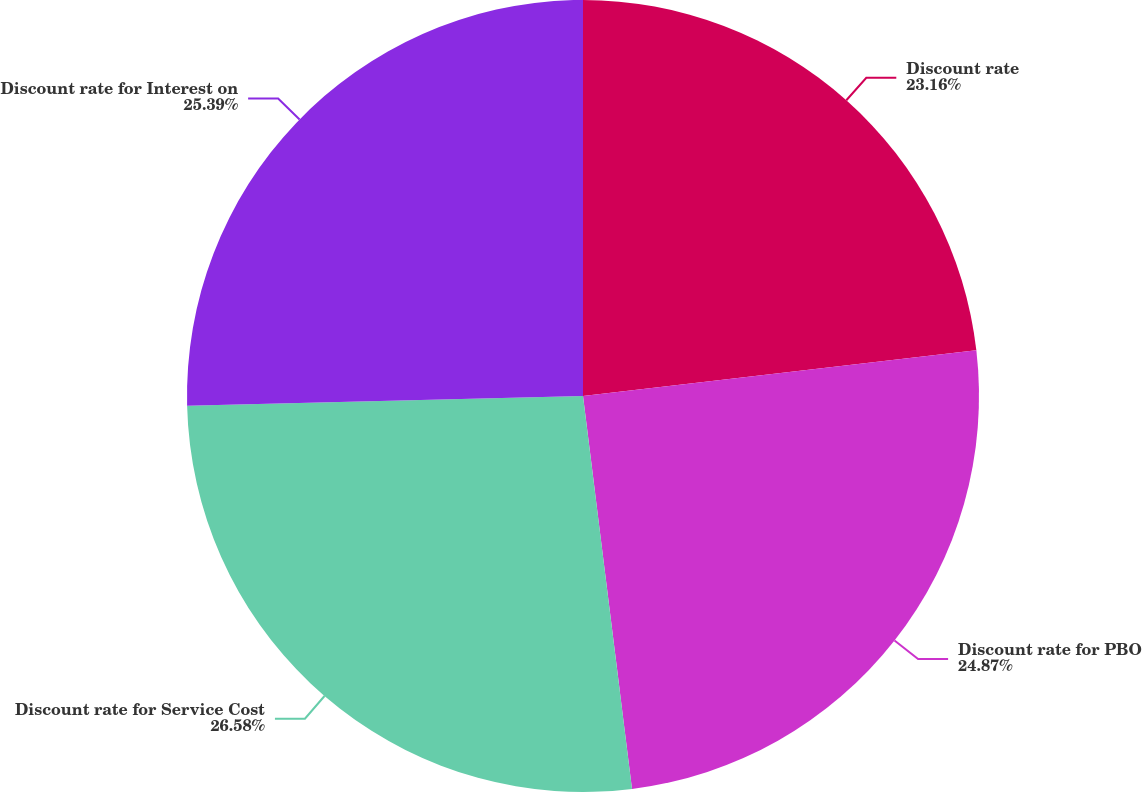Convert chart to OTSL. <chart><loc_0><loc_0><loc_500><loc_500><pie_chart><fcel>Discount rate<fcel>Discount rate for PBO<fcel>Discount rate for Service Cost<fcel>Discount rate for Interest on<nl><fcel>23.16%<fcel>24.87%<fcel>26.59%<fcel>25.39%<nl></chart> 